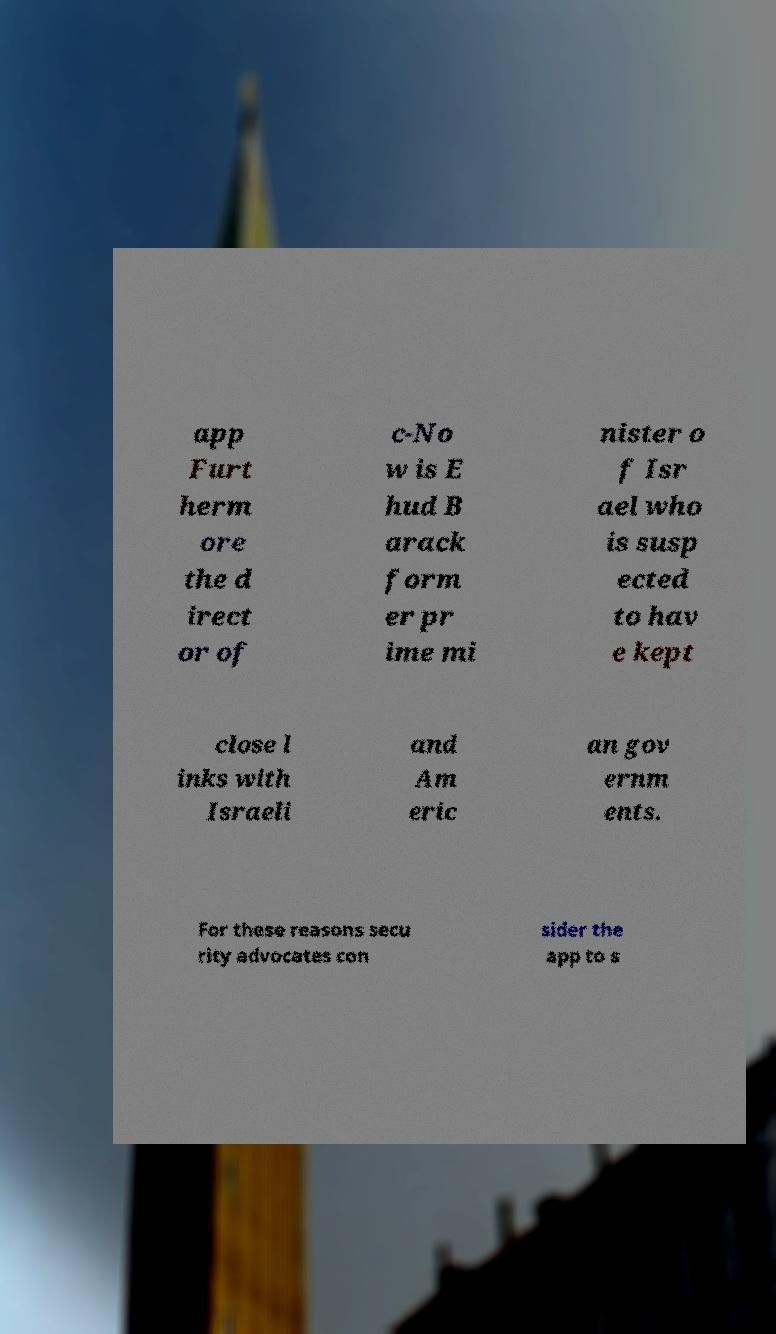There's text embedded in this image that I need extracted. Can you transcribe it verbatim? app Furt herm ore the d irect or of c-No w is E hud B arack form er pr ime mi nister o f Isr ael who is susp ected to hav e kept close l inks with Israeli and Am eric an gov ernm ents. For these reasons secu rity advocates con sider the app to s 